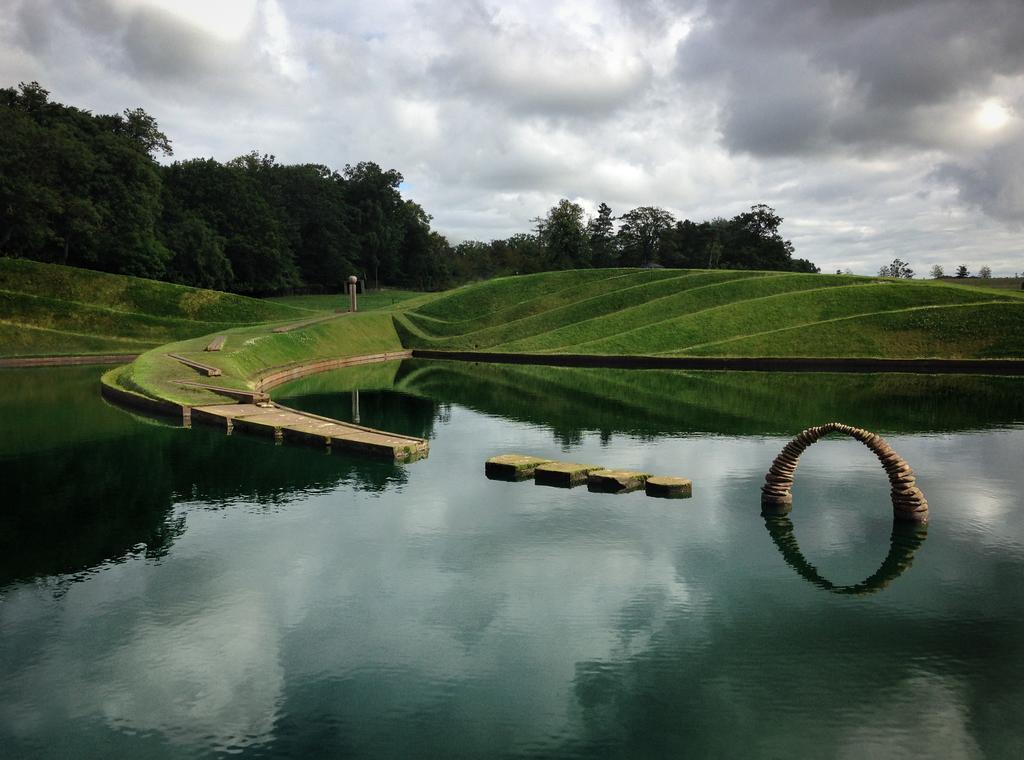Describe this image in one or two sentences. In this picture we can see water, here we can see the grass and some objects and in the background we can see trees, sky. 